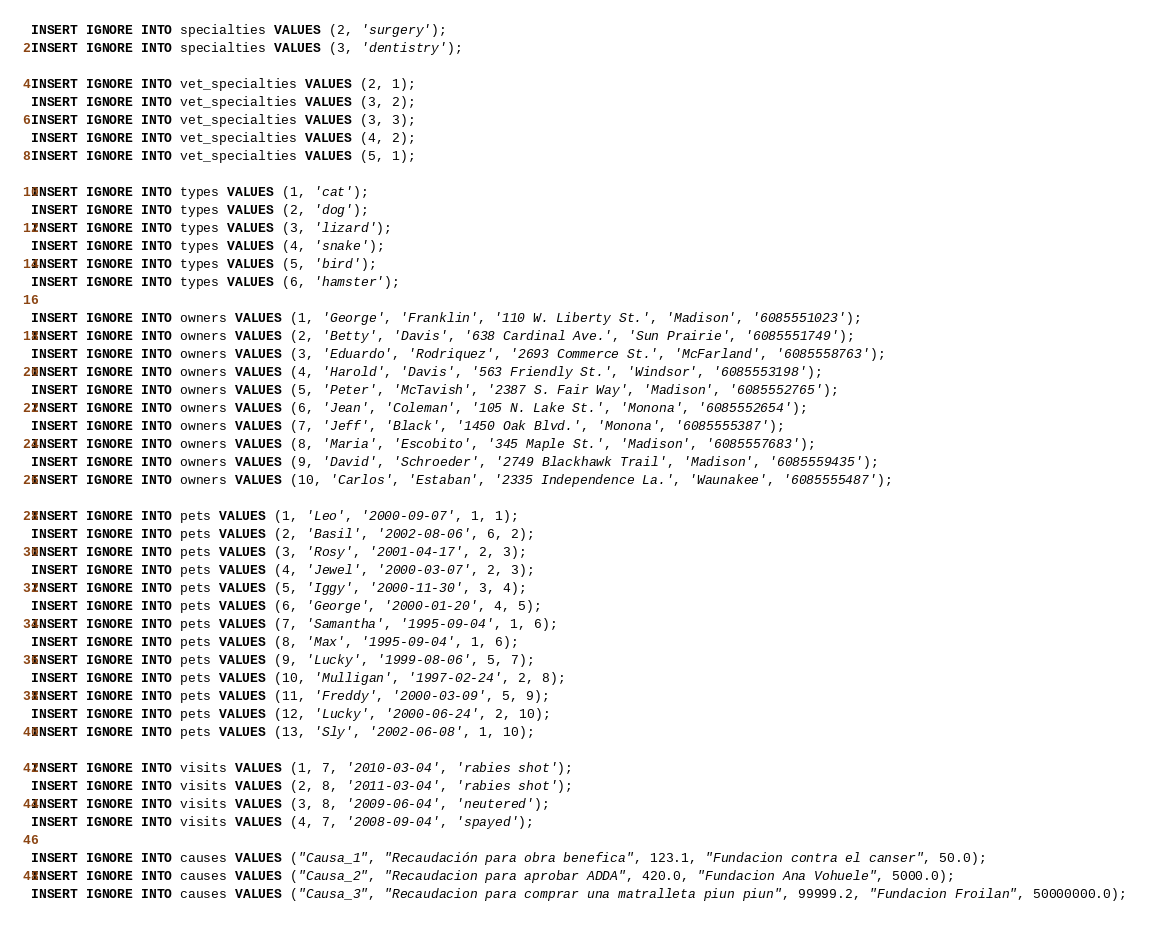Convert code to text. <code><loc_0><loc_0><loc_500><loc_500><_SQL_>INSERT IGNORE INTO specialties VALUES (2, 'surgery');
INSERT IGNORE INTO specialties VALUES (3, 'dentistry');

INSERT IGNORE INTO vet_specialties VALUES (2, 1);
INSERT IGNORE INTO vet_specialties VALUES (3, 2);
INSERT IGNORE INTO vet_specialties VALUES (3, 3);
INSERT IGNORE INTO vet_specialties VALUES (4, 2);
INSERT IGNORE INTO vet_specialties VALUES (5, 1);

INSERT IGNORE INTO types VALUES (1, 'cat');
INSERT IGNORE INTO types VALUES (2, 'dog');
INSERT IGNORE INTO types VALUES (3, 'lizard');
INSERT IGNORE INTO types VALUES (4, 'snake');
INSERT IGNORE INTO types VALUES (5, 'bird');
INSERT IGNORE INTO types VALUES (6, 'hamster');

INSERT IGNORE INTO owners VALUES (1, 'George', 'Franklin', '110 W. Liberty St.', 'Madison', '6085551023');
INSERT IGNORE INTO owners VALUES (2, 'Betty', 'Davis', '638 Cardinal Ave.', 'Sun Prairie', '6085551749');
INSERT IGNORE INTO owners VALUES (3, 'Eduardo', 'Rodriquez', '2693 Commerce St.', 'McFarland', '6085558763');
INSERT IGNORE INTO owners VALUES (4, 'Harold', 'Davis', '563 Friendly St.', 'Windsor', '6085553198');
INSERT IGNORE INTO owners VALUES (5, 'Peter', 'McTavish', '2387 S. Fair Way', 'Madison', '6085552765');
INSERT IGNORE INTO owners VALUES (6, 'Jean', 'Coleman', '105 N. Lake St.', 'Monona', '6085552654');
INSERT IGNORE INTO owners VALUES (7, 'Jeff', 'Black', '1450 Oak Blvd.', 'Monona', '6085555387');
INSERT IGNORE INTO owners VALUES (8, 'Maria', 'Escobito', '345 Maple St.', 'Madison', '6085557683');
INSERT IGNORE INTO owners VALUES (9, 'David', 'Schroeder', '2749 Blackhawk Trail', 'Madison', '6085559435');
INSERT IGNORE INTO owners VALUES (10, 'Carlos', 'Estaban', '2335 Independence La.', 'Waunakee', '6085555487');

INSERT IGNORE INTO pets VALUES (1, 'Leo', '2000-09-07', 1, 1);
INSERT IGNORE INTO pets VALUES (2, 'Basil', '2002-08-06', 6, 2);
INSERT IGNORE INTO pets VALUES (3, 'Rosy', '2001-04-17', 2, 3);
INSERT IGNORE INTO pets VALUES (4, 'Jewel', '2000-03-07', 2, 3);
INSERT IGNORE INTO pets VALUES (5, 'Iggy', '2000-11-30', 3, 4);
INSERT IGNORE INTO pets VALUES (6, 'George', '2000-01-20', 4, 5);
INSERT IGNORE INTO pets VALUES (7, 'Samantha', '1995-09-04', 1, 6);
INSERT IGNORE INTO pets VALUES (8, 'Max', '1995-09-04', 1, 6);
INSERT IGNORE INTO pets VALUES (9, 'Lucky', '1999-08-06', 5, 7);
INSERT IGNORE INTO pets VALUES (10, 'Mulligan', '1997-02-24', 2, 8);
INSERT IGNORE INTO pets VALUES (11, 'Freddy', '2000-03-09', 5, 9);
INSERT IGNORE INTO pets VALUES (12, 'Lucky', '2000-06-24', 2, 10);
INSERT IGNORE INTO pets VALUES (13, 'Sly', '2002-06-08', 1, 10);

INSERT IGNORE INTO visits VALUES (1, 7, '2010-03-04', 'rabies shot');
INSERT IGNORE INTO visits VALUES (2, 8, '2011-03-04', 'rabies shot');
INSERT IGNORE INTO visits VALUES (3, 8, '2009-06-04', 'neutered');
INSERT IGNORE INTO visits VALUES (4, 7, '2008-09-04', 'spayed');

INSERT IGNORE INTO causes VALUES ("Causa_1", "Recaudación para obra benefica", 123.1, "Fundacion contra el canser", 50.0);
INSERT IGNORE INTO causes VALUES ("Causa_2", "Recaudacion para aprobar ADDA", 420.0, "Fundacion Ana Vohuele", 5000.0);
INSERT IGNORE INTO causes VALUES ("Causa_3", "Recaudacion para comprar una matralleta piun piun", 99999.2, "Fundacion Froilan", 50000000.0);

</code> 